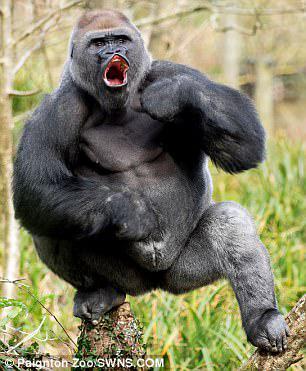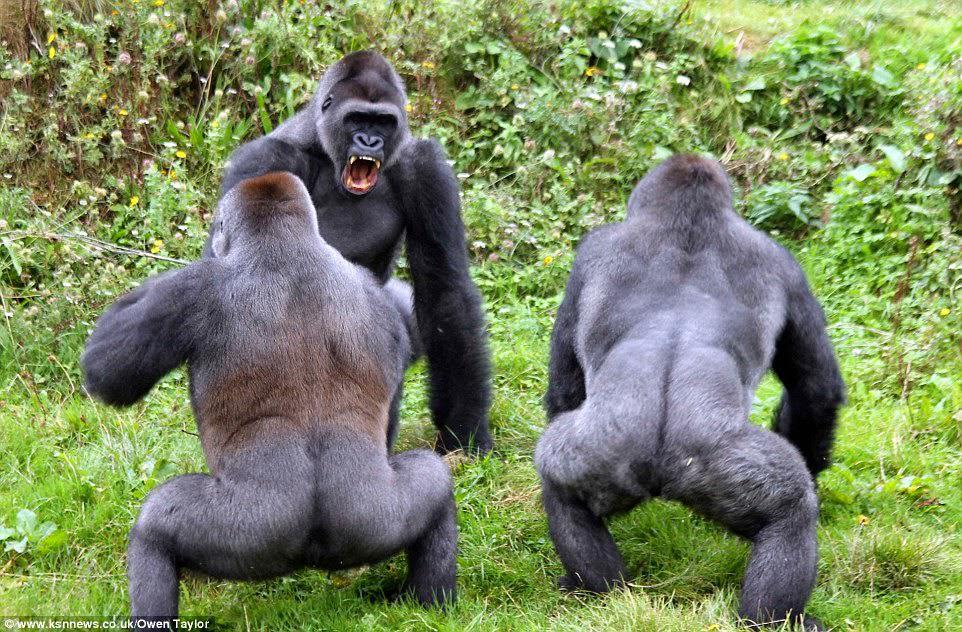The first image is the image on the left, the second image is the image on the right. Assess this claim about the two images: "At least one of the gorillas has an open mouth.". Correct or not? Answer yes or no. Yes. The first image is the image on the left, the second image is the image on the right. Given the left and right images, does the statement "A total of four gorillas are shown, and left and right images do not contain the same number of gorillas." hold true? Answer yes or no. Yes. 